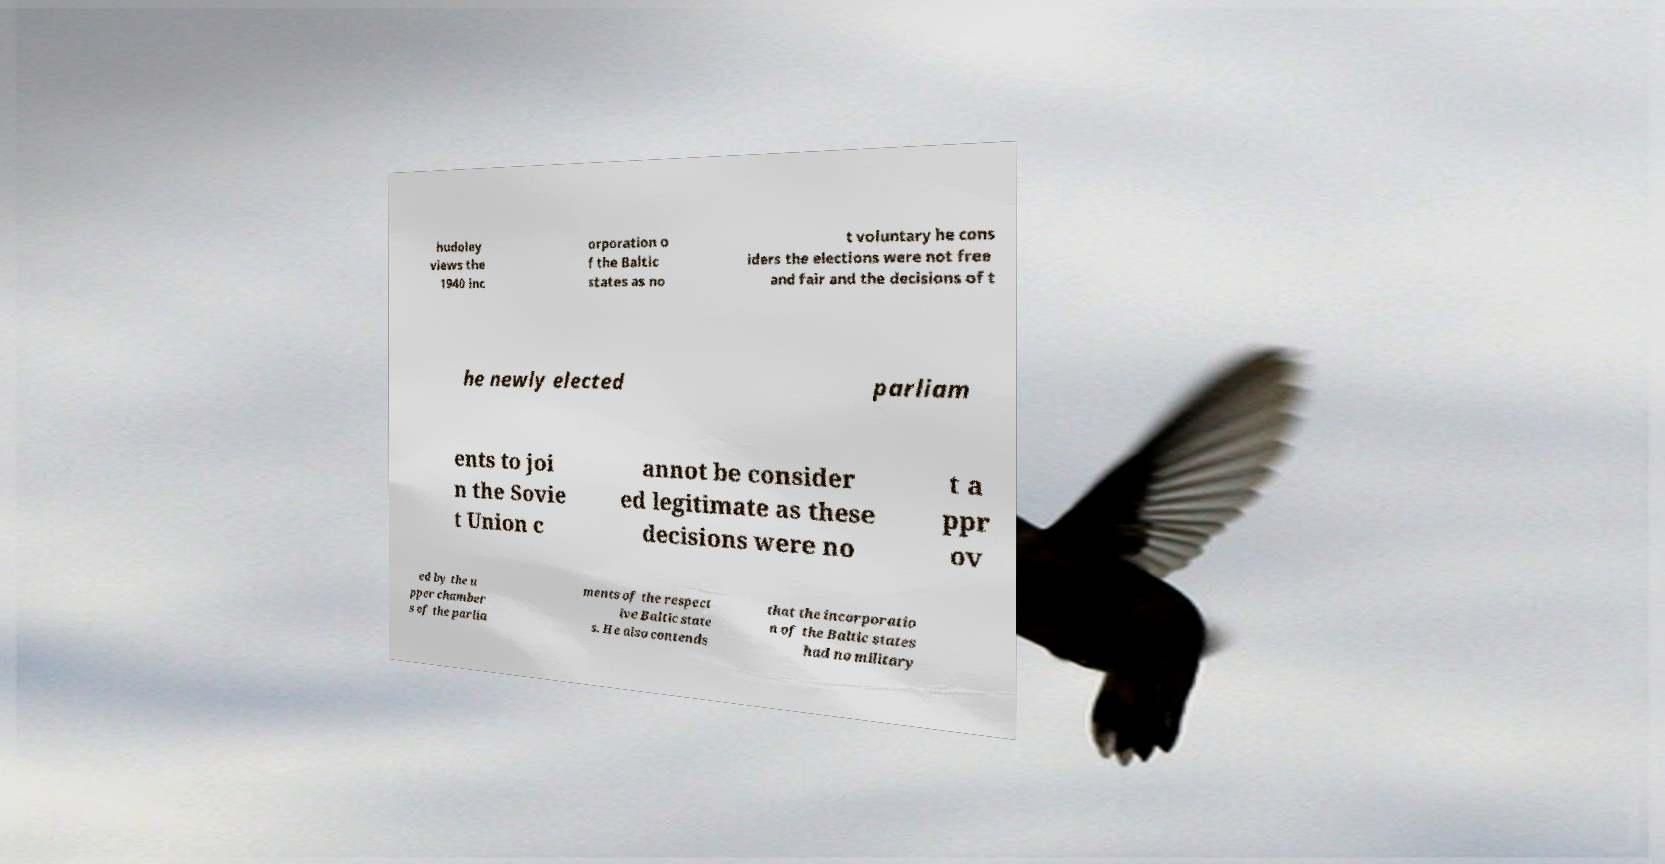What messages or text are displayed in this image? I need them in a readable, typed format. hudoley views the 1940 inc orporation o f the Baltic states as no t voluntary he cons iders the elections were not free and fair and the decisions of t he newly elected parliam ents to joi n the Sovie t Union c annot be consider ed legitimate as these decisions were no t a ppr ov ed by the u pper chamber s of the parlia ments of the respect ive Baltic state s. He also contends that the incorporatio n of the Baltic states had no military 